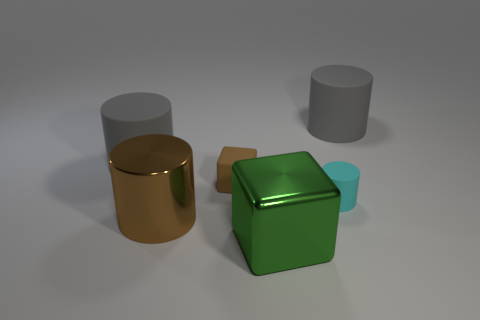Subtract all cyan cylinders. How many cylinders are left? 3 Add 2 brown metallic spheres. How many objects exist? 8 Subtract all brown blocks. How many blocks are left? 1 Subtract all red blocks. How many gray cylinders are left? 2 Subtract all cubes. How many objects are left? 4 Subtract 0 blue spheres. How many objects are left? 6 Subtract all red cylinders. Subtract all blue blocks. How many cylinders are left? 4 Subtract all tiny purple rubber cubes. Subtract all matte cylinders. How many objects are left? 3 Add 6 large green objects. How many large green objects are left? 7 Add 3 rubber blocks. How many rubber blocks exist? 4 